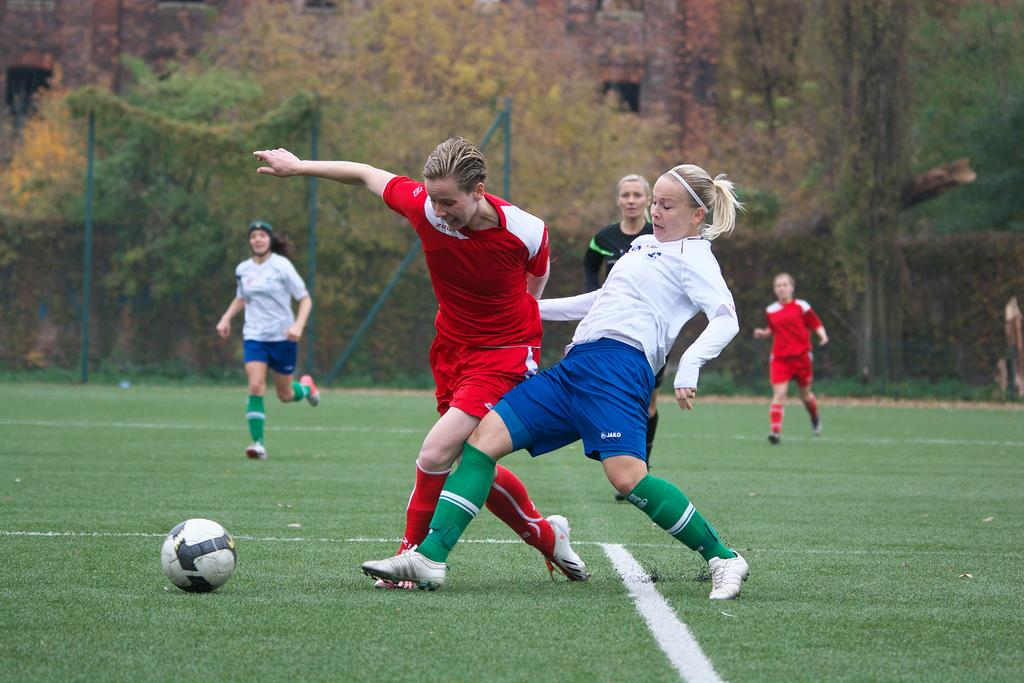What object can be seen in the image? There is a ball in the image. Who is present in the image? There is a group of people in the image. What are the people doing in the image? The people are running on the ground. What is the boundary in the image? There is a fence in the image. What can be seen in the distance in the image? There are trees visible in the background of the image. What type of donkey can be heard making a voice in the image? There is no donkey or voice present in the image; it only features a ball, a group of people running, a fence, and trees in the background. 